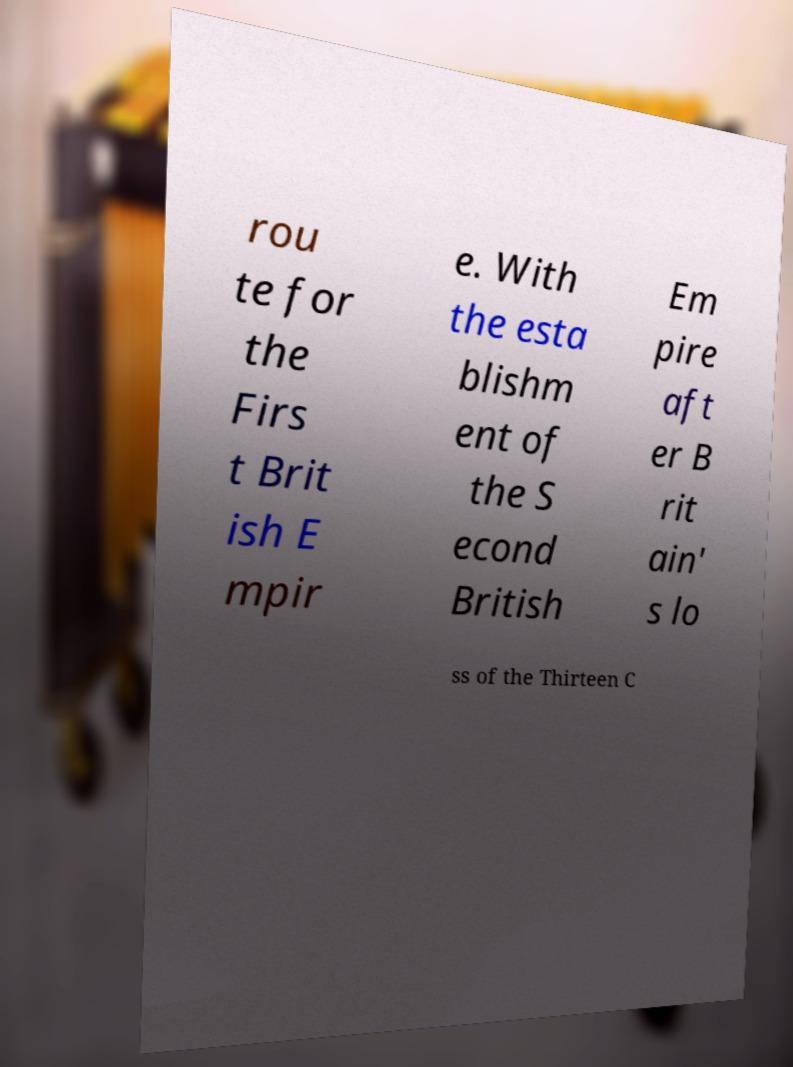For documentation purposes, I need the text within this image transcribed. Could you provide that? rou te for the Firs t Brit ish E mpir e. With the esta blishm ent of the S econd British Em pire aft er B rit ain' s lo ss of the Thirteen C 